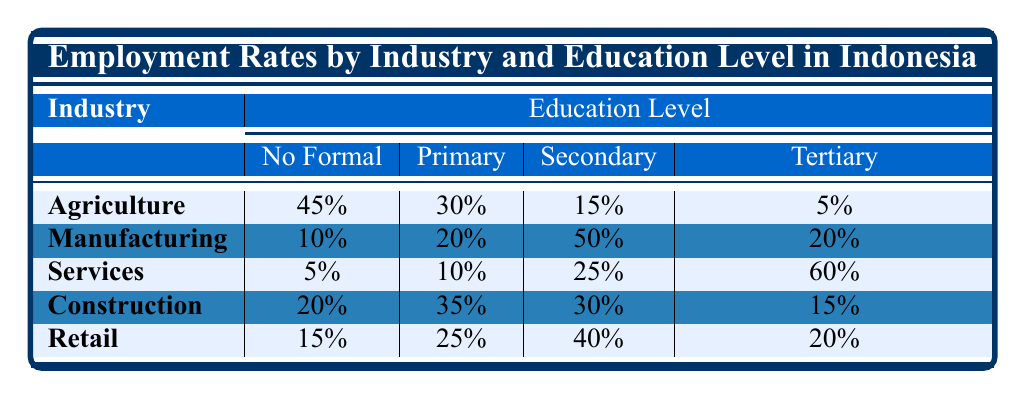What is the employment rate for the Agriculture sector among those with No Formal Education? The table shows that the employment rate for the Agriculture sector with No Formal Education is 45%.
Answer: 45% Which industry has the highest employment rate for Tertiary Education? The table indicates that the Services sector has the highest employment rate for Tertiary Education at 60%.
Answer: 60% What is the total employment rate for individuals with Primary Education across all industries? The employment rates for Primary Education are: Agriculture (30%), Manufacturing (20%), Services (10%), Construction (35%), and Retail (25%). Adding these values gives 30 + 20 + 10 + 35 + 25 = 120%.
Answer: 120% Is the employment rate for those with Secondary Education in Manufacturing greater than that in Retail? The table shows that the employment rate for Secondary Education in Manufacturing is 50% and in Retail it is 40%. Therefore, 50% is greater than 40%.
Answer: Yes What is the difference in employment rates for No Formal Education between Agriculture and Services? The employment rate for No Formal Education in Agriculture is 45%, while in Services it is 5%. The difference is 45 - 5 = 40%.
Answer: 40% Which education level has the lowest employment rates across all industries? Looking at the table, the employment rate for No Formal Education is the highest in Agriculture (45%) and the lowest is in Services (5%).
Answer: No Formal Education If you combine the employment rates of Tertiary Education for Agriculture and Construction, what is the total? The employment rates for Tertiary Education are: Agriculture (5%) and Construction (15%). Adding these gives 5 + 15 = 20%.
Answer: 20% If a person has Primary Education, which industry would provide the highest chance of employment? From the table, Primary Education has the highest employment rate in Construction at 35%.
Answer: Construction What is the average employment rate for Secondary Education across all mentioned industries? The secondary education rates are: Agriculture (15%), Manufacturing (50%), Services (25%), Construction (30%), and Retail (40%). Adding these gives 15 + 50 + 25 + 30 + 40 = 160%. Dividing by the number of industries (5) gives an average of 160 / 5 = 32%.
Answer: 32% Which education level in the Retail industry has a lower employment rate than that of Tertiary Education in Agriculture? The employment rate for Tertiary Education in Agriculture is 5%, while the rates for Primary and Secondary in Retail are 25% and 40% respectively. All are higher than 5%.
Answer: None 